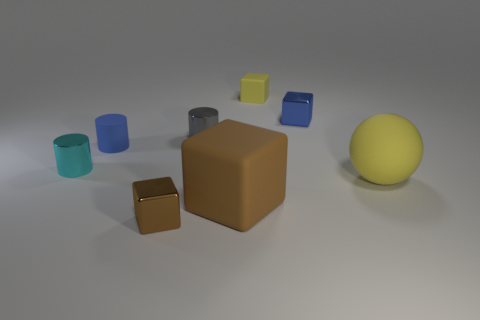Subtract all tiny cyan metallic cylinders. How many cylinders are left? 2 Subtract all yellow cubes. How many cubes are left? 3 Subtract all cylinders. How many objects are left? 5 Subtract 1 cubes. How many cubes are left? 3 Add 2 big matte blocks. How many objects exist? 10 Subtract 1 yellow balls. How many objects are left? 7 Subtract all red cubes. Subtract all cyan balls. How many cubes are left? 4 Subtract all cyan blocks. How many cyan cylinders are left? 1 Subtract all large red blocks. Subtract all tiny matte cylinders. How many objects are left? 7 Add 3 tiny blue things. How many tiny blue things are left? 5 